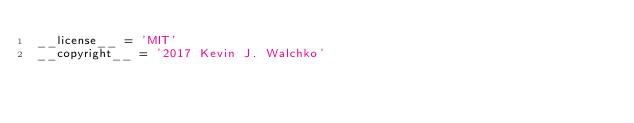Convert code to text. <code><loc_0><loc_0><loc_500><loc_500><_Python_>__license__ = 'MIT'
__copyright__ = '2017 Kevin J. Walchko'
</code> 